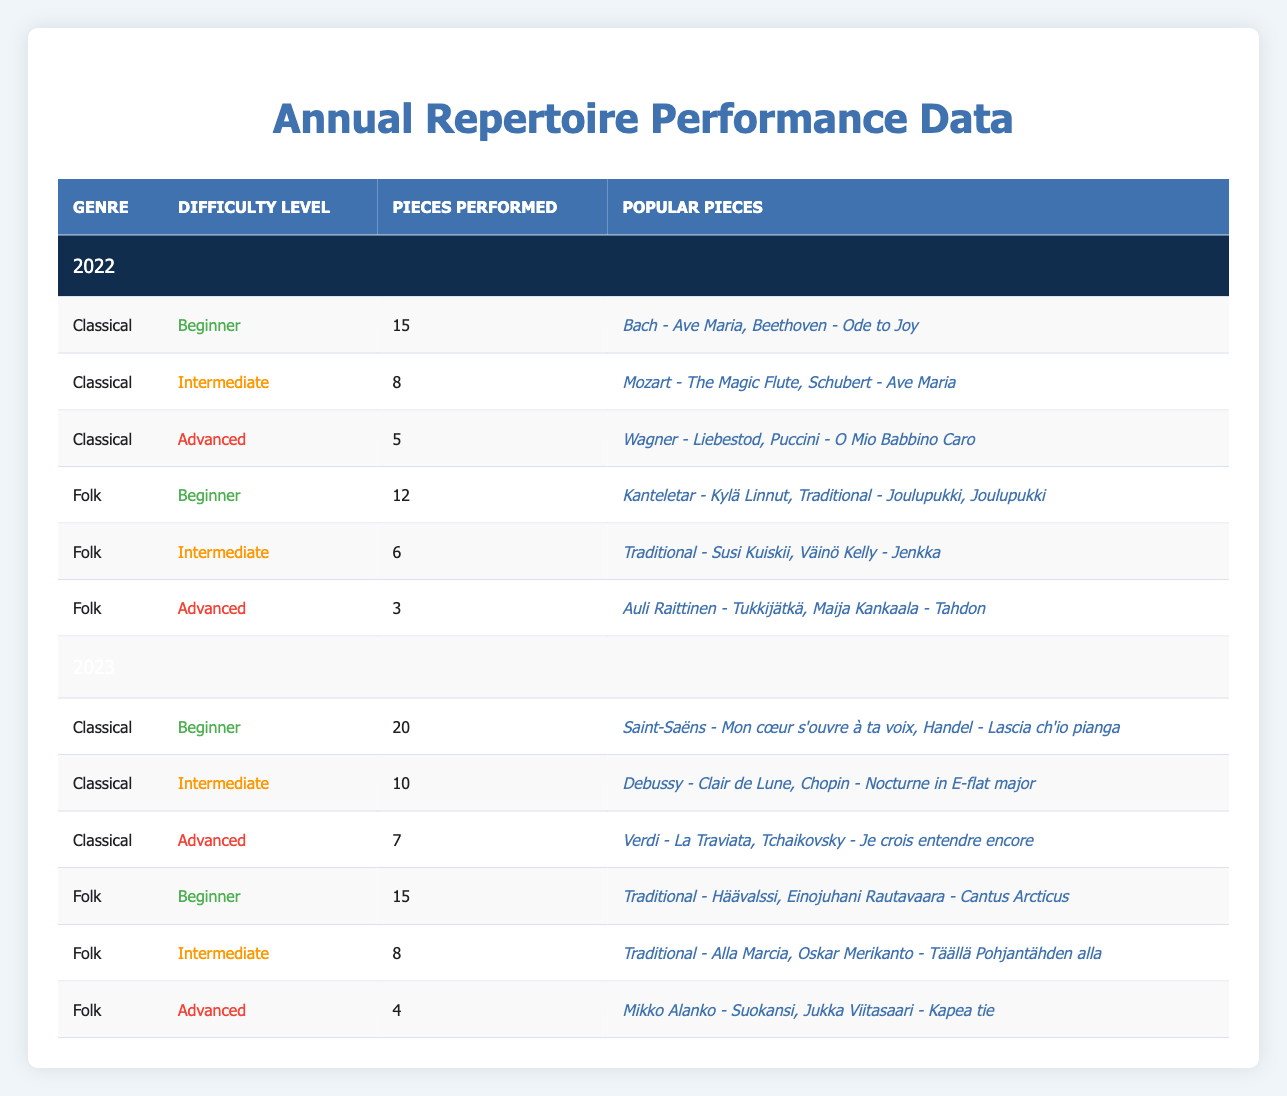What was the total number of pieces performed in 2022? To find the total number of pieces performed in 2022, sum the performance counts across all genres and difficulty levels for that year: 15 (Classical Beginner) + 8 (Classical Intermediate) + 5 (Classical Advanced) + 12 (Folk Beginner) + 6 (Folk Intermediate) + 3 (Folk Advanced) = 49.
Answer: 49 Which genre had the highest number of performances at the beginner level in 2023? In 2023, the Classical genre had 20 performances, while the Folk genre had 15 at the beginner level. Since 20 is greater than 15, Classical is the genre with the highest performances at the beginner level.
Answer: Classical How many more performances were there in Classical genre in 2023 compared to 2022? First, find the total performances in Classical for both years: In 2022 there were 15 (Beginner) + 8 (Intermediate) + 5 (Advanced) = 28. In 2023 there were 20 (Beginner) + 10 (Intermediate) + 7 (Advanced) = 37. Now subtract the two totals: 37 - 28 = 9.
Answer: 9 Did the number of advanced pieces performed in Folk genre increase from 2022 to 2023? In 2022, there were 3 advanced Folk performances. In 2023, there were 4. Since 4 is greater than 3, the number of advanced pieces performed in Folk increased.
Answer: Yes What is the average number of pieces performed per genre in 2023? In 2023, there are 6 entries (3 Classical and 3 Folk). Their total performance counts are 20 (Beginner) + 10 (Intermediate) + 7 (Advanced) + 15 (Beginner) + 8 (Intermediate) + 4 (Advanced) = 74. Divide the total by the number of genres (6): 74 / 6 ≈ 12.33.
Answer: 12.33 Which popular piece was performed the least in 2022? Review the popular pieces for each Folk and Classical performance in 2022. Each genre's least performed piece based on their performance counts must be identified. For Folk, "Auli Raittinen - Tukkijätkä" and "Maija Kankaala - Tahdon" were both tied at 3, which is the least among Folk's advanced level. In comparison, the least for Classical is 5 pieces. Thus, Auli Raittinen's work is the least performed.
Answer: Auli Raittinen - Tukkijätkä How many total performances were there across all genres and difficulty levels in 2022? For 2022, sum the pieces performed across genres and difficulty levels: 15 + 8 + 5 + 12 + 6 + 3 = 49.
Answer: 49 Was "Saint-Saëns - Mon cœur s'ouvre à ta voix" a popular piece performed in 2022? This piece is listed under the Classical Beginner level for 2023, while the 2022 performance does not include it. Thus, it was not performed in 2022.
Answer: No What is the difference in the number of advanced performances between Folk and Classical in 2023? In 2023, Folk had 4 advanced performances, while Classical had 7. Subtract the Folk advanced performances from Classical: 7 - 4 = 3.
Answer: 3 How many popular pieces are listed for the Intermediate level in Folk for both years combined? In 2022, Folk Intermediate had 2 popular pieces and in 2023, it also had 2. Adding them gives: 2 + 2 = 4.
Answer: 4 Which genre saw an increase in performances from 2022 to 2023 in the Intermediate difficulty? In 2022, Classical had 8 and Folk had 6. In 2023, Classical had 10 and Folk had 8. Both genres increased; however, Folk went from 6 to 8, thus a total increase of 2 performances.
Answer: Both, but Classical had a larger increase 